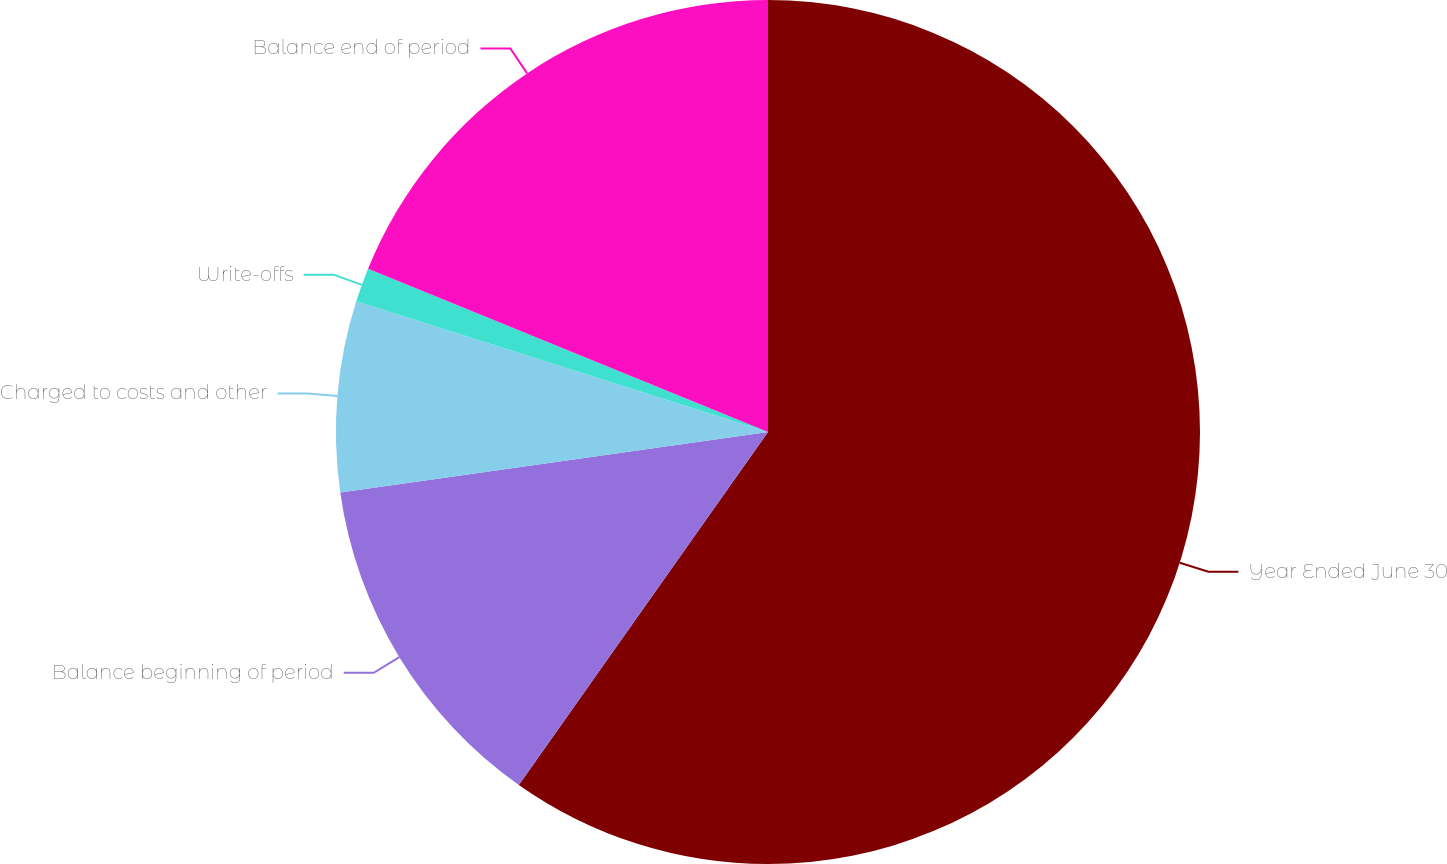<chart> <loc_0><loc_0><loc_500><loc_500><pie_chart><fcel>Year Ended June 30<fcel>Balance beginning of period<fcel>Charged to costs and other<fcel>Write-offs<fcel>Balance end of period<nl><fcel>59.79%<fcel>12.98%<fcel>7.13%<fcel>1.28%<fcel>18.83%<nl></chart> 